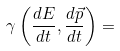<formula> <loc_0><loc_0><loc_500><loc_500>\gamma \left ( { \frac { d E } { d t } } , { \frac { d { \vec { p } } } { d t } } \right ) =</formula> 